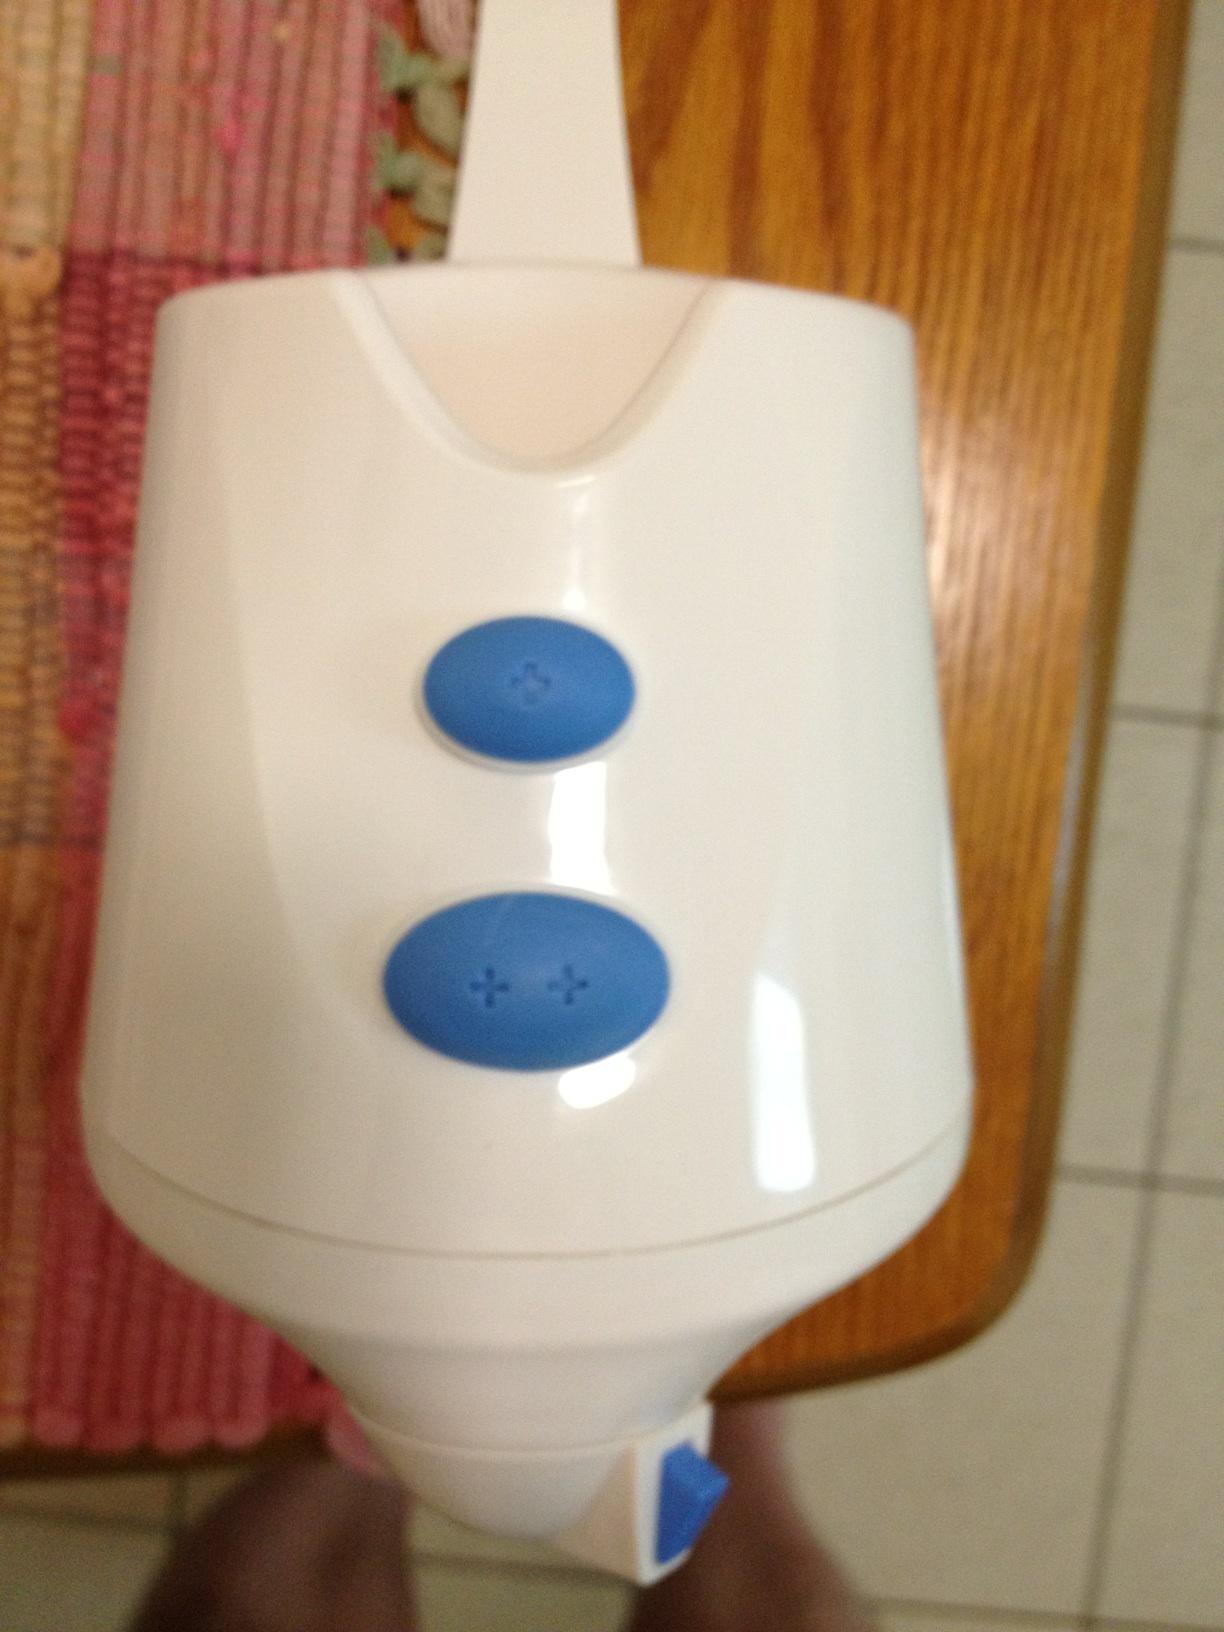Can you explain the purpose of this device? This device appears to be some kind of appliance, perhaps for kitchen or personal care use. The buttons with plus signs indicate that it likely has adjustable settings, probably to control its speed or intensity. How do you think it works? Based on the design, it probably operates electronically. You would press the buttons with the plus signs to increase the settings or start the device. The exact mechanism might involve internal motors or heating elements, depending on its function. 